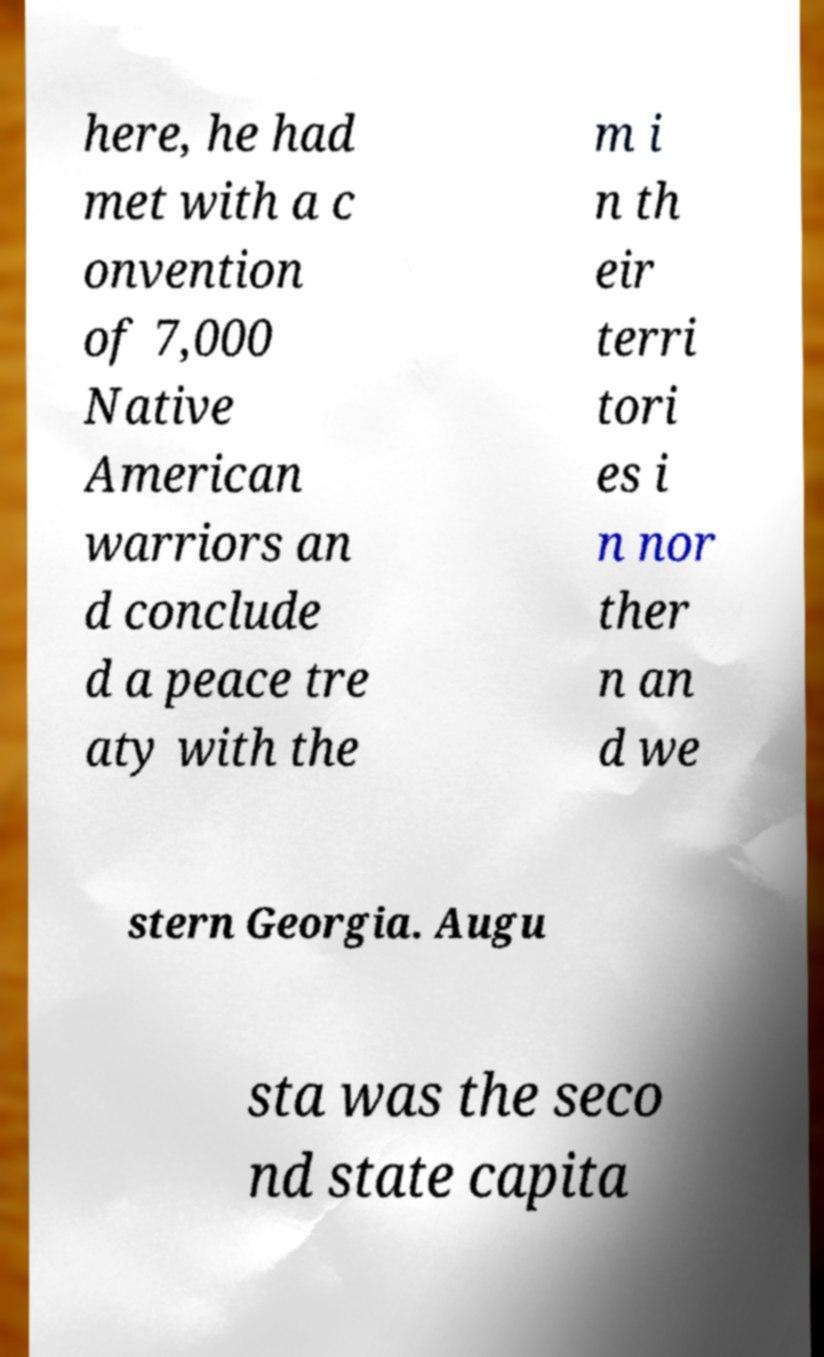I need the written content from this picture converted into text. Can you do that? here, he had met with a c onvention of 7,000 Native American warriors an d conclude d a peace tre aty with the m i n th eir terri tori es i n nor ther n an d we stern Georgia. Augu sta was the seco nd state capita 